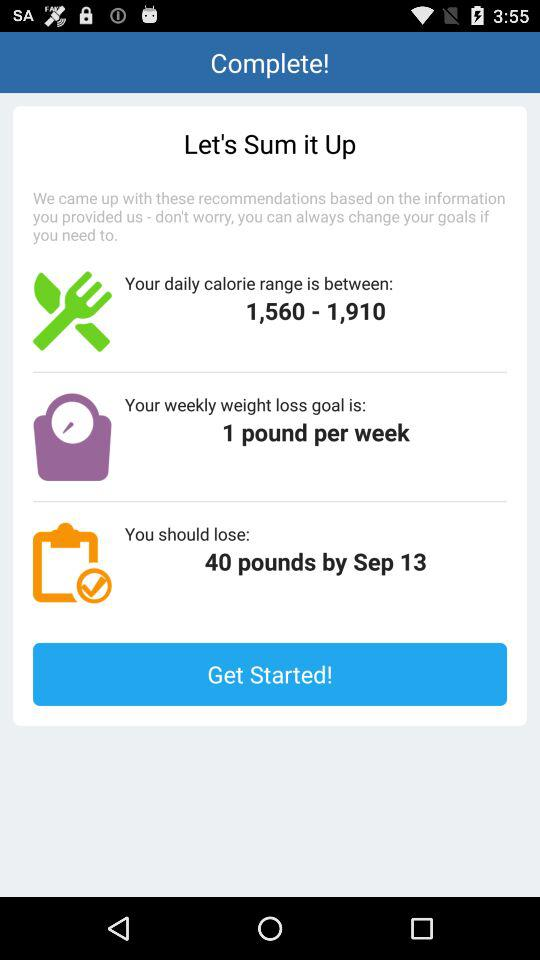How many pounds should I lose by Sep 13?
Answer the question using a single word or phrase. 40 